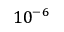<formula> <loc_0><loc_0><loc_500><loc_500>1 0 ^ { - 6 }</formula> 